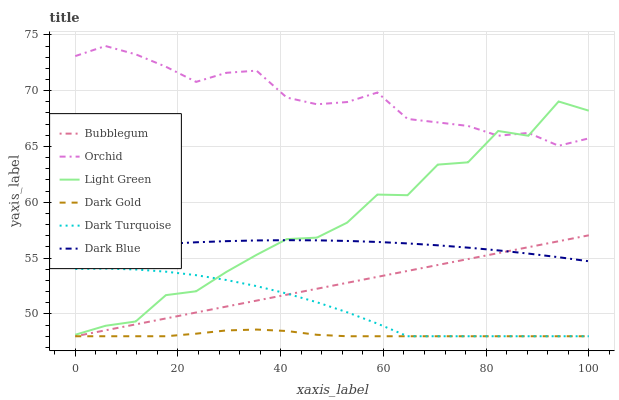Does Dark Gold have the minimum area under the curve?
Answer yes or no. Yes. Does Orchid have the maximum area under the curve?
Answer yes or no. Yes. Does Dark Turquoise have the minimum area under the curve?
Answer yes or no. No. Does Dark Turquoise have the maximum area under the curve?
Answer yes or no. No. Is Bubblegum the smoothest?
Answer yes or no. Yes. Is Light Green the roughest?
Answer yes or no. Yes. Is Dark Turquoise the smoothest?
Answer yes or no. No. Is Dark Turquoise the roughest?
Answer yes or no. No. Does Dark Gold have the lowest value?
Answer yes or no. Yes. Does Dark Blue have the lowest value?
Answer yes or no. No. Does Orchid have the highest value?
Answer yes or no. Yes. Does Dark Turquoise have the highest value?
Answer yes or no. No. Is Dark Turquoise less than Dark Blue?
Answer yes or no. Yes. Is Orchid greater than Dark Turquoise?
Answer yes or no. Yes. Does Bubblegum intersect Dark Blue?
Answer yes or no. Yes. Is Bubblegum less than Dark Blue?
Answer yes or no. No. Is Bubblegum greater than Dark Blue?
Answer yes or no. No. Does Dark Turquoise intersect Dark Blue?
Answer yes or no. No. 